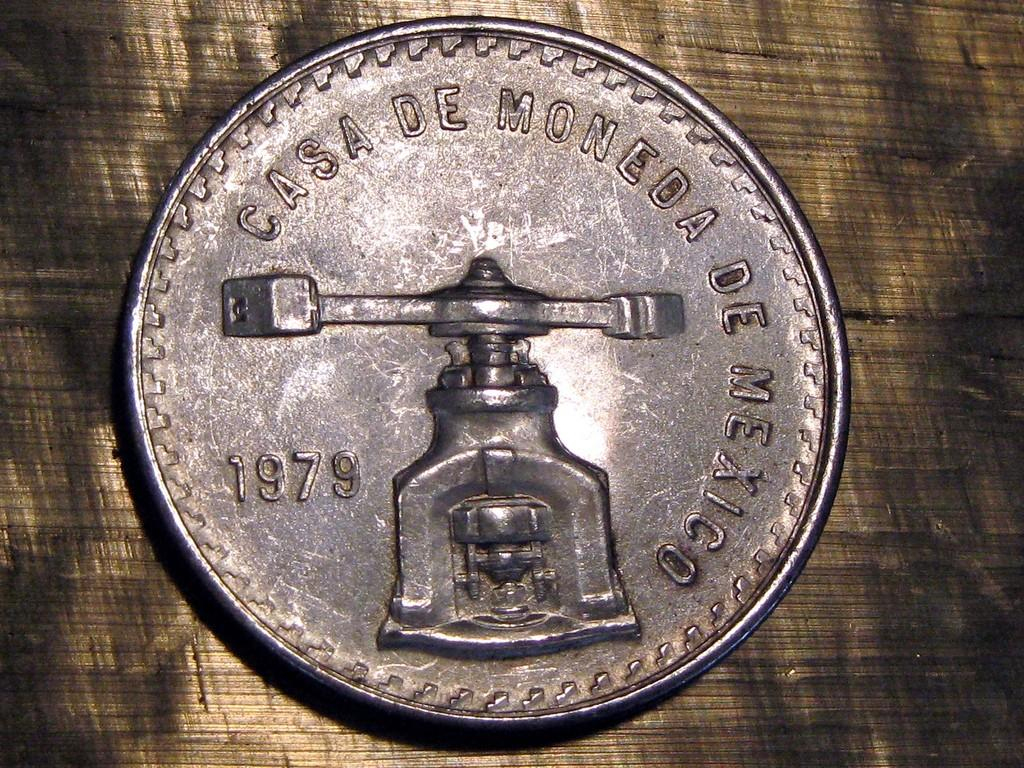<image>
Summarize the visual content of the image. The old coin shown was made in 1979. 